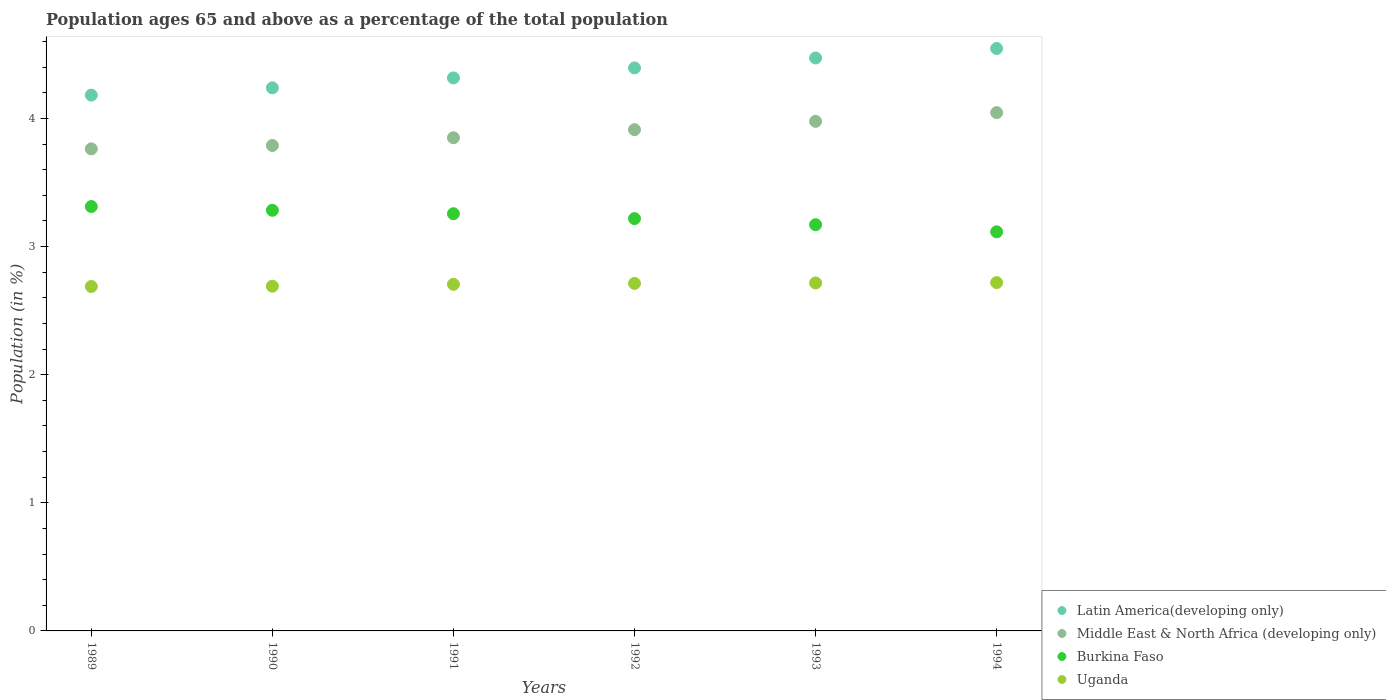What is the percentage of the population ages 65 and above in Burkina Faso in 1994?
Provide a succinct answer. 3.11. Across all years, what is the maximum percentage of the population ages 65 and above in Uganda?
Ensure brevity in your answer.  2.72. Across all years, what is the minimum percentage of the population ages 65 and above in Uganda?
Offer a very short reply. 2.69. In which year was the percentage of the population ages 65 and above in Middle East & North Africa (developing only) maximum?
Your answer should be compact. 1994. What is the total percentage of the population ages 65 and above in Latin America(developing only) in the graph?
Give a very brief answer. 26.15. What is the difference between the percentage of the population ages 65 and above in Middle East & North Africa (developing only) in 1991 and that in 1994?
Make the answer very short. -0.2. What is the difference between the percentage of the population ages 65 and above in Middle East & North Africa (developing only) in 1993 and the percentage of the population ages 65 and above in Burkina Faso in 1991?
Your response must be concise. 0.72. What is the average percentage of the population ages 65 and above in Middle East & North Africa (developing only) per year?
Give a very brief answer. 3.89. In the year 1993, what is the difference between the percentage of the population ages 65 and above in Middle East & North Africa (developing only) and percentage of the population ages 65 and above in Latin America(developing only)?
Keep it short and to the point. -0.49. In how many years, is the percentage of the population ages 65 and above in Latin America(developing only) greater than 4?
Your response must be concise. 6. What is the ratio of the percentage of the population ages 65 and above in Middle East & North Africa (developing only) in 1991 to that in 1993?
Offer a very short reply. 0.97. What is the difference between the highest and the second highest percentage of the population ages 65 and above in Latin America(developing only)?
Provide a succinct answer. 0.07. What is the difference between the highest and the lowest percentage of the population ages 65 and above in Middle East & North Africa (developing only)?
Make the answer very short. 0.28. In how many years, is the percentage of the population ages 65 and above in Burkina Faso greater than the average percentage of the population ages 65 and above in Burkina Faso taken over all years?
Your response must be concise. 3. Is the sum of the percentage of the population ages 65 and above in Burkina Faso in 1992 and 1994 greater than the maximum percentage of the population ages 65 and above in Uganda across all years?
Your response must be concise. Yes. Is it the case that in every year, the sum of the percentage of the population ages 65 and above in Latin America(developing only) and percentage of the population ages 65 and above in Burkina Faso  is greater than the sum of percentage of the population ages 65 and above in Middle East & North Africa (developing only) and percentage of the population ages 65 and above in Uganda?
Provide a succinct answer. No. Is it the case that in every year, the sum of the percentage of the population ages 65 and above in Uganda and percentage of the population ages 65 and above in Middle East & North Africa (developing only)  is greater than the percentage of the population ages 65 and above in Latin America(developing only)?
Provide a short and direct response. Yes. Does the percentage of the population ages 65 and above in Uganda monotonically increase over the years?
Ensure brevity in your answer.  Yes. Is the percentage of the population ages 65 and above in Middle East & North Africa (developing only) strictly greater than the percentage of the population ages 65 and above in Burkina Faso over the years?
Keep it short and to the point. Yes. Are the values on the major ticks of Y-axis written in scientific E-notation?
Your response must be concise. No. Does the graph contain any zero values?
Offer a terse response. No. Does the graph contain grids?
Provide a short and direct response. No. Where does the legend appear in the graph?
Your response must be concise. Bottom right. How many legend labels are there?
Keep it short and to the point. 4. How are the legend labels stacked?
Provide a short and direct response. Vertical. What is the title of the graph?
Your response must be concise. Population ages 65 and above as a percentage of the total population. Does "Central Europe" appear as one of the legend labels in the graph?
Provide a short and direct response. No. What is the label or title of the Y-axis?
Give a very brief answer. Population (in %). What is the Population (in %) in Latin America(developing only) in 1989?
Give a very brief answer. 4.18. What is the Population (in %) of Middle East & North Africa (developing only) in 1989?
Ensure brevity in your answer.  3.76. What is the Population (in %) of Burkina Faso in 1989?
Make the answer very short. 3.31. What is the Population (in %) in Uganda in 1989?
Make the answer very short. 2.69. What is the Population (in %) of Latin America(developing only) in 1990?
Your answer should be compact. 4.24. What is the Population (in %) of Middle East & North Africa (developing only) in 1990?
Your answer should be very brief. 3.79. What is the Population (in %) of Burkina Faso in 1990?
Give a very brief answer. 3.28. What is the Population (in %) of Uganda in 1990?
Ensure brevity in your answer.  2.69. What is the Population (in %) in Latin America(developing only) in 1991?
Provide a succinct answer. 4.32. What is the Population (in %) in Middle East & North Africa (developing only) in 1991?
Your response must be concise. 3.85. What is the Population (in %) of Burkina Faso in 1991?
Offer a very short reply. 3.26. What is the Population (in %) in Uganda in 1991?
Provide a short and direct response. 2.71. What is the Population (in %) in Latin America(developing only) in 1992?
Your response must be concise. 4.39. What is the Population (in %) in Middle East & North Africa (developing only) in 1992?
Your response must be concise. 3.91. What is the Population (in %) of Burkina Faso in 1992?
Your answer should be compact. 3.22. What is the Population (in %) in Uganda in 1992?
Your answer should be compact. 2.71. What is the Population (in %) in Latin America(developing only) in 1993?
Your answer should be compact. 4.47. What is the Population (in %) in Middle East & North Africa (developing only) in 1993?
Make the answer very short. 3.98. What is the Population (in %) of Burkina Faso in 1993?
Provide a succinct answer. 3.17. What is the Population (in %) in Uganda in 1993?
Offer a terse response. 2.72. What is the Population (in %) of Latin America(developing only) in 1994?
Give a very brief answer. 4.55. What is the Population (in %) of Middle East & North Africa (developing only) in 1994?
Offer a terse response. 4.04. What is the Population (in %) in Burkina Faso in 1994?
Offer a terse response. 3.11. What is the Population (in %) of Uganda in 1994?
Your answer should be compact. 2.72. Across all years, what is the maximum Population (in %) in Latin America(developing only)?
Your answer should be very brief. 4.55. Across all years, what is the maximum Population (in %) in Middle East & North Africa (developing only)?
Provide a short and direct response. 4.04. Across all years, what is the maximum Population (in %) of Burkina Faso?
Make the answer very short. 3.31. Across all years, what is the maximum Population (in %) in Uganda?
Your answer should be compact. 2.72. Across all years, what is the minimum Population (in %) in Latin America(developing only)?
Your answer should be very brief. 4.18. Across all years, what is the minimum Population (in %) of Middle East & North Africa (developing only)?
Make the answer very short. 3.76. Across all years, what is the minimum Population (in %) of Burkina Faso?
Your response must be concise. 3.11. Across all years, what is the minimum Population (in %) in Uganda?
Provide a short and direct response. 2.69. What is the total Population (in %) of Latin America(developing only) in the graph?
Your response must be concise. 26.15. What is the total Population (in %) in Middle East & North Africa (developing only) in the graph?
Your answer should be very brief. 23.33. What is the total Population (in %) in Burkina Faso in the graph?
Make the answer very short. 19.35. What is the total Population (in %) in Uganda in the graph?
Your answer should be compact. 16.23. What is the difference between the Population (in %) in Latin America(developing only) in 1989 and that in 1990?
Provide a short and direct response. -0.06. What is the difference between the Population (in %) in Middle East & North Africa (developing only) in 1989 and that in 1990?
Your response must be concise. -0.03. What is the difference between the Population (in %) in Burkina Faso in 1989 and that in 1990?
Your answer should be very brief. 0.03. What is the difference between the Population (in %) of Uganda in 1989 and that in 1990?
Your answer should be very brief. -0. What is the difference between the Population (in %) in Latin America(developing only) in 1989 and that in 1991?
Provide a short and direct response. -0.13. What is the difference between the Population (in %) in Middle East & North Africa (developing only) in 1989 and that in 1991?
Ensure brevity in your answer.  -0.09. What is the difference between the Population (in %) of Burkina Faso in 1989 and that in 1991?
Keep it short and to the point. 0.06. What is the difference between the Population (in %) in Uganda in 1989 and that in 1991?
Ensure brevity in your answer.  -0.02. What is the difference between the Population (in %) in Latin America(developing only) in 1989 and that in 1992?
Make the answer very short. -0.21. What is the difference between the Population (in %) in Middle East & North Africa (developing only) in 1989 and that in 1992?
Offer a very short reply. -0.15. What is the difference between the Population (in %) in Burkina Faso in 1989 and that in 1992?
Make the answer very short. 0.09. What is the difference between the Population (in %) in Uganda in 1989 and that in 1992?
Your answer should be very brief. -0.02. What is the difference between the Population (in %) in Latin America(developing only) in 1989 and that in 1993?
Make the answer very short. -0.29. What is the difference between the Population (in %) of Middle East & North Africa (developing only) in 1989 and that in 1993?
Your response must be concise. -0.21. What is the difference between the Population (in %) of Burkina Faso in 1989 and that in 1993?
Provide a short and direct response. 0.14. What is the difference between the Population (in %) in Uganda in 1989 and that in 1993?
Give a very brief answer. -0.03. What is the difference between the Population (in %) in Latin America(developing only) in 1989 and that in 1994?
Your response must be concise. -0.36. What is the difference between the Population (in %) in Middle East & North Africa (developing only) in 1989 and that in 1994?
Make the answer very short. -0.28. What is the difference between the Population (in %) in Burkina Faso in 1989 and that in 1994?
Provide a short and direct response. 0.2. What is the difference between the Population (in %) of Uganda in 1989 and that in 1994?
Keep it short and to the point. -0.03. What is the difference between the Population (in %) in Latin America(developing only) in 1990 and that in 1991?
Your response must be concise. -0.08. What is the difference between the Population (in %) in Middle East & North Africa (developing only) in 1990 and that in 1991?
Provide a succinct answer. -0.06. What is the difference between the Population (in %) of Burkina Faso in 1990 and that in 1991?
Your response must be concise. 0.03. What is the difference between the Population (in %) in Uganda in 1990 and that in 1991?
Give a very brief answer. -0.01. What is the difference between the Population (in %) in Latin America(developing only) in 1990 and that in 1992?
Give a very brief answer. -0.16. What is the difference between the Population (in %) of Middle East & North Africa (developing only) in 1990 and that in 1992?
Offer a terse response. -0.12. What is the difference between the Population (in %) of Burkina Faso in 1990 and that in 1992?
Offer a terse response. 0.07. What is the difference between the Population (in %) in Uganda in 1990 and that in 1992?
Make the answer very short. -0.02. What is the difference between the Population (in %) in Latin America(developing only) in 1990 and that in 1993?
Offer a terse response. -0.23. What is the difference between the Population (in %) in Middle East & North Africa (developing only) in 1990 and that in 1993?
Provide a succinct answer. -0.19. What is the difference between the Population (in %) of Burkina Faso in 1990 and that in 1993?
Your answer should be compact. 0.11. What is the difference between the Population (in %) of Uganda in 1990 and that in 1993?
Keep it short and to the point. -0.03. What is the difference between the Population (in %) in Latin America(developing only) in 1990 and that in 1994?
Offer a terse response. -0.31. What is the difference between the Population (in %) of Middle East & North Africa (developing only) in 1990 and that in 1994?
Make the answer very short. -0.26. What is the difference between the Population (in %) in Burkina Faso in 1990 and that in 1994?
Give a very brief answer. 0.17. What is the difference between the Population (in %) of Uganda in 1990 and that in 1994?
Offer a very short reply. -0.03. What is the difference between the Population (in %) in Latin America(developing only) in 1991 and that in 1992?
Provide a succinct answer. -0.08. What is the difference between the Population (in %) in Middle East & North Africa (developing only) in 1991 and that in 1992?
Your answer should be very brief. -0.06. What is the difference between the Population (in %) in Burkina Faso in 1991 and that in 1992?
Offer a very short reply. 0.04. What is the difference between the Population (in %) of Uganda in 1991 and that in 1992?
Offer a terse response. -0.01. What is the difference between the Population (in %) of Latin America(developing only) in 1991 and that in 1993?
Your answer should be very brief. -0.16. What is the difference between the Population (in %) in Middle East & North Africa (developing only) in 1991 and that in 1993?
Offer a very short reply. -0.13. What is the difference between the Population (in %) of Burkina Faso in 1991 and that in 1993?
Give a very brief answer. 0.09. What is the difference between the Population (in %) of Uganda in 1991 and that in 1993?
Offer a terse response. -0.01. What is the difference between the Population (in %) of Latin America(developing only) in 1991 and that in 1994?
Provide a short and direct response. -0.23. What is the difference between the Population (in %) of Middle East & North Africa (developing only) in 1991 and that in 1994?
Offer a very short reply. -0.2. What is the difference between the Population (in %) in Burkina Faso in 1991 and that in 1994?
Your answer should be very brief. 0.14. What is the difference between the Population (in %) of Uganda in 1991 and that in 1994?
Ensure brevity in your answer.  -0.01. What is the difference between the Population (in %) of Latin America(developing only) in 1992 and that in 1993?
Offer a very short reply. -0.08. What is the difference between the Population (in %) of Middle East & North Africa (developing only) in 1992 and that in 1993?
Your answer should be very brief. -0.07. What is the difference between the Population (in %) in Burkina Faso in 1992 and that in 1993?
Provide a succinct answer. 0.05. What is the difference between the Population (in %) in Uganda in 1992 and that in 1993?
Your answer should be compact. -0. What is the difference between the Population (in %) of Latin America(developing only) in 1992 and that in 1994?
Make the answer very short. -0.15. What is the difference between the Population (in %) in Middle East & North Africa (developing only) in 1992 and that in 1994?
Provide a short and direct response. -0.13. What is the difference between the Population (in %) in Burkina Faso in 1992 and that in 1994?
Offer a very short reply. 0.1. What is the difference between the Population (in %) in Uganda in 1992 and that in 1994?
Your answer should be compact. -0.01. What is the difference between the Population (in %) of Latin America(developing only) in 1993 and that in 1994?
Your answer should be very brief. -0.07. What is the difference between the Population (in %) of Middle East & North Africa (developing only) in 1993 and that in 1994?
Make the answer very short. -0.07. What is the difference between the Population (in %) of Burkina Faso in 1993 and that in 1994?
Provide a succinct answer. 0.06. What is the difference between the Population (in %) of Uganda in 1993 and that in 1994?
Keep it short and to the point. -0. What is the difference between the Population (in %) in Latin America(developing only) in 1989 and the Population (in %) in Middle East & North Africa (developing only) in 1990?
Your answer should be compact. 0.39. What is the difference between the Population (in %) of Latin America(developing only) in 1989 and the Population (in %) of Burkina Faso in 1990?
Keep it short and to the point. 0.9. What is the difference between the Population (in %) in Latin America(developing only) in 1989 and the Population (in %) in Uganda in 1990?
Give a very brief answer. 1.49. What is the difference between the Population (in %) in Middle East & North Africa (developing only) in 1989 and the Population (in %) in Burkina Faso in 1990?
Keep it short and to the point. 0.48. What is the difference between the Population (in %) of Middle East & North Africa (developing only) in 1989 and the Population (in %) of Uganda in 1990?
Your response must be concise. 1.07. What is the difference between the Population (in %) in Burkina Faso in 1989 and the Population (in %) in Uganda in 1990?
Your answer should be very brief. 0.62. What is the difference between the Population (in %) in Latin America(developing only) in 1989 and the Population (in %) in Middle East & North Africa (developing only) in 1991?
Ensure brevity in your answer.  0.33. What is the difference between the Population (in %) of Latin America(developing only) in 1989 and the Population (in %) of Burkina Faso in 1991?
Provide a short and direct response. 0.93. What is the difference between the Population (in %) in Latin America(developing only) in 1989 and the Population (in %) in Uganda in 1991?
Your answer should be very brief. 1.48. What is the difference between the Population (in %) of Middle East & North Africa (developing only) in 1989 and the Population (in %) of Burkina Faso in 1991?
Ensure brevity in your answer.  0.51. What is the difference between the Population (in %) of Middle East & North Africa (developing only) in 1989 and the Population (in %) of Uganda in 1991?
Give a very brief answer. 1.06. What is the difference between the Population (in %) in Burkina Faso in 1989 and the Population (in %) in Uganda in 1991?
Your answer should be very brief. 0.61. What is the difference between the Population (in %) in Latin America(developing only) in 1989 and the Population (in %) in Middle East & North Africa (developing only) in 1992?
Offer a very short reply. 0.27. What is the difference between the Population (in %) in Latin America(developing only) in 1989 and the Population (in %) in Burkina Faso in 1992?
Your answer should be compact. 0.96. What is the difference between the Population (in %) in Latin America(developing only) in 1989 and the Population (in %) in Uganda in 1992?
Your answer should be very brief. 1.47. What is the difference between the Population (in %) in Middle East & North Africa (developing only) in 1989 and the Population (in %) in Burkina Faso in 1992?
Offer a terse response. 0.54. What is the difference between the Population (in %) in Middle East & North Africa (developing only) in 1989 and the Population (in %) in Uganda in 1992?
Give a very brief answer. 1.05. What is the difference between the Population (in %) of Burkina Faso in 1989 and the Population (in %) of Uganda in 1992?
Ensure brevity in your answer.  0.6. What is the difference between the Population (in %) of Latin America(developing only) in 1989 and the Population (in %) of Middle East & North Africa (developing only) in 1993?
Keep it short and to the point. 0.2. What is the difference between the Population (in %) in Latin America(developing only) in 1989 and the Population (in %) in Burkina Faso in 1993?
Keep it short and to the point. 1.01. What is the difference between the Population (in %) in Latin America(developing only) in 1989 and the Population (in %) in Uganda in 1993?
Keep it short and to the point. 1.47. What is the difference between the Population (in %) of Middle East & North Africa (developing only) in 1989 and the Population (in %) of Burkina Faso in 1993?
Your answer should be very brief. 0.59. What is the difference between the Population (in %) in Middle East & North Africa (developing only) in 1989 and the Population (in %) in Uganda in 1993?
Give a very brief answer. 1.05. What is the difference between the Population (in %) of Burkina Faso in 1989 and the Population (in %) of Uganda in 1993?
Ensure brevity in your answer.  0.6. What is the difference between the Population (in %) in Latin America(developing only) in 1989 and the Population (in %) in Middle East & North Africa (developing only) in 1994?
Your response must be concise. 0.14. What is the difference between the Population (in %) in Latin America(developing only) in 1989 and the Population (in %) in Burkina Faso in 1994?
Keep it short and to the point. 1.07. What is the difference between the Population (in %) of Latin America(developing only) in 1989 and the Population (in %) of Uganda in 1994?
Ensure brevity in your answer.  1.46. What is the difference between the Population (in %) of Middle East & North Africa (developing only) in 1989 and the Population (in %) of Burkina Faso in 1994?
Keep it short and to the point. 0.65. What is the difference between the Population (in %) in Middle East & North Africa (developing only) in 1989 and the Population (in %) in Uganda in 1994?
Provide a short and direct response. 1.04. What is the difference between the Population (in %) in Burkina Faso in 1989 and the Population (in %) in Uganda in 1994?
Provide a short and direct response. 0.59. What is the difference between the Population (in %) of Latin America(developing only) in 1990 and the Population (in %) of Middle East & North Africa (developing only) in 1991?
Provide a succinct answer. 0.39. What is the difference between the Population (in %) in Latin America(developing only) in 1990 and the Population (in %) in Burkina Faso in 1991?
Keep it short and to the point. 0.98. What is the difference between the Population (in %) of Latin America(developing only) in 1990 and the Population (in %) of Uganda in 1991?
Provide a succinct answer. 1.53. What is the difference between the Population (in %) of Middle East & North Africa (developing only) in 1990 and the Population (in %) of Burkina Faso in 1991?
Ensure brevity in your answer.  0.53. What is the difference between the Population (in %) of Middle East & North Africa (developing only) in 1990 and the Population (in %) of Uganda in 1991?
Your response must be concise. 1.08. What is the difference between the Population (in %) of Burkina Faso in 1990 and the Population (in %) of Uganda in 1991?
Your response must be concise. 0.58. What is the difference between the Population (in %) in Latin America(developing only) in 1990 and the Population (in %) in Middle East & North Africa (developing only) in 1992?
Your response must be concise. 0.33. What is the difference between the Population (in %) in Latin America(developing only) in 1990 and the Population (in %) in Burkina Faso in 1992?
Offer a terse response. 1.02. What is the difference between the Population (in %) in Latin America(developing only) in 1990 and the Population (in %) in Uganda in 1992?
Give a very brief answer. 1.53. What is the difference between the Population (in %) in Middle East & North Africa (developing only) in 1990 and the Population (in %) in Burkina Faso in 1992?
Your answer should be very brief. 0.57. What is the difference between the Population (in %) of Middle East & North Africa (developing only) in 1990 and the Population (in %) of Uganda in 1992?
Provide a succinct answer. 1.08. What is the difference between the Population (in %) of Burkina Faso in 1990 and the Population (in %) of Uganda in 1992?
Ensure brevity in your answer.  0.57. What is the difference between the Population (in %) of Latin America(developing only) in 1990 and the Population (in %) of Middle East & North Africa (developing only) in 1993?
Your response must be concise. 0.26. What is the difference between the Population (in %) in Latin America(developing only) in 1990 and the Population (in %) in Burkina Faso in 1993?
Ensure brevity in your answer.  1.07. What is the difference between the Population (in %) in Latin America(developing only) in 1990 and the Population (in %) in Uganda in 1993?
Ensure brevity in your answer.  1.52. What is the difference between the Population (in %) of Middle East & North Africa (developing only) in 1990 and the Population (in %) of Burkina Faso in 1993?
Give a very brief answer. 0.62. What is the difference between the Population (in %) of Middle East & North Africa (developing only) in 1990 and the Population (in %) of Uganda in 1993?
Give a very brief answer. 1.07. What is the difference between the Population (in %) of Burkina Faso in 1990 and the Population (in %) of Uganda in 1993?
Your response must be concise. 0.57. What is the difference between the Population (in %) in Latin America(developing only) in 1990 and the Population (in %) in Middle East & North Africa (developing only) in 1994?
Provide a short and direct response. 0.19. What is the difference between the Population (in %) of Latin America(developing only) in 1990 and the Population (in %) of Burkina Faso in 1994?
Give a very brief answer. 1.12. What is the difference between the Population (in %) in Latin America(developing only) in 1990 and the Population (in %) in Uganda in 1994?
Your response must be concise. 1.52. What is the difference between the Population (in %) of Middle East & North Africa (developing only) in 1990 and the Population (in %) of Burkina Faso in 1994?
Your answer should be very brief. 0.67. What is the difference between the Population (in %) in Middle East & North Africa (developing only) in 1990 and the Population (in %) in Uganda in 1994?
Your answer should be compact. 1.07. What is the difference between the Population (in %) in Burkina Faso in 1990 and the Population (in %) in Uganda in 1994?
Provide a short and direct response. 0.56. What is the difference between the Population (in %) in Latin America(developing only) in 1991 and the Population (in %) in Middle East & North Africa (developing only) in 1992?
Your answer should be very brief. 0.4. What is the difference between the Population (in %) of Latin America(developing only) in 1991 and the Population (in %) of Burkina Faso in 1992?
Keep it short and to the point. 1.1. What is the difference between the Population (in %) of Latin America(developing only) in 1991 and the Population (in %) of Uganda in 1992?
Offer a very short reply. 1.6. What is the difference between the Population (in %) in Middle East & North Africa (developing only) in 1991 and the Population (in %) in Burkina Faso in 1992?
Offer a terse response. 0.63. What is the difference between the Population (in %) in Middle East & North Africa (developing only) in 1991 and the Population (in %) in Uganda in 1992?
Your answer should be compact. 1.14. What is the difference between the Population (in %) in Burkina Faso in 1991 and the Population (in %) in Uganda in 1992?
Give a very brief answer. 0.54. What is the difference between the Population (in %) of Latin America(developing only) in 1991 and the Population (in %) of Middle East & North Africa (developing only) in 1993?
Give a very brief answer. 0.34. What is the difference between the Population (in %) of Latin America(developing only) in 1991 and the Population (in %) of Burkina Faso in 1993?
Offer a terse response. 1.15. What is the difference between the Population (in %) in Latin America(developing only) in 1991 and the Population (in %) in Uganda in 1993?
Ensure brevity in your answer.  1.6. What is the difference between the Population (in %) in Middle East & North Africa (developing only) in 1991 and the Population (in %) in Burkina Faso in 1993?
Provide a short and direct response. 0.68. What is the difference between the Population (in %) in Middle East & North Africa (developing only) in 1991 and the Population (in %) in Uganda in 1993?
Give a very brief answer. 1.13. What is the difference between the Population (in %) of Burkina Faso in 1991 and the Population (in %) of Uganda in 1993?
Your response must be concise. 0.54. What is the difference between the Population (in %) in Latin America(developing only) in 1991 and the Population (in %) in Middle East & North Africa (developing only) in 1994?
Make the answer very short. 0.27. What is the difference between the Population (in %) in Latin America(developing only) in 1991 and the Population (in %) in Burkina Faso in 1994?
Your response must be concise. 1.2. What is the difference between the Population (in %) of Latin America(developing only) in 1991 and the Population (in %) of Uganda in 1994?
Provide a short and direct response. 1.6. What is the difference between the Population (in %) in Middle East & North Africa (developing only) in 1991 and the Population (in %) in Burkina Faso in 1994?
Ensure brevity in your answer.  0.73. What is the difference between the Population (in %) of Middle East & North Africa (developing only) in 1991 and the Population (in %) of Uganda in 1994?
Ensure brevity in your answer.  1.13. What is the difference between the Population (in %) in Burkina Faso in 1991 and the Population (in %) in Uganda in 1994?
Make the answer very short. 0.54. What is the difference between the Population (in %) in Latin America(developing only) in 1992 and the Population (in %) in Middle East & North Africa (developing only) in 1993?
Offer a terse response. 0.42. What is the difference between the Population (in %) of Latin America(developing only) in 1992 and the Population (in %) of Burkina Faso in 1993?
Ensure brevity in your answer.  1.22. What is the difference between the Population (in %) of Latin America(developing only) in 1992 and the Population (in %) of Uganda in 1993?
Your response must be concise. 1.68. What is the difference between the Population (in %) of Middle East & North Africa (developing only) in 1992 and the Population (in %) of Burkina Faso in 1993?
Offer a terse response. 0.74. What is the difference between the Population (in %) in Middle East & North Africa (developing only) in 1992 and the Population (in %) in Uganda in 1993?
Give a very brief answer. 1.2. What is the difference between the Population (in %) of Burkina Faso in 1992 and the Population (in %) of Uganda in 1993?
Your answer should be compact. 0.5. What is the difference between the Population (in %) in Latin America(developing only) in 1992 and the Population (in %) in Middle East & North Africa (developing only) in 1994?
Ensure brevity in your answer.  0.35. What is the difference between the Population (in %) of Latin America(developing only) in 1992 and the Population (in %) of Burkina Faso in 1994?
Give a very brief answer. 1.28. What is the difference between the Population (in %) of Latin America(developing only) in 1992 and the Population (in %) of Uganda in 1994?
Your response must be concise. 1.68. What is the difference between the Population (in %) of Middle East & North Africa (developing only) in 1992 and the Population (in %) of Burkina Faso in 1994?
Make the answer very short. 0.8. What is the difference between the Population (in %) in Middle East & North Africa (developing only) in 1992 and the Population (in %) in Uganda in 1994?
Provide a short and direct response. 1.19. What is the difference between the Population (in %) of Burkina Faso in 1992 and the Population (in %) of Uganda in 1994?
Ensure brevity in your answer.  0.5. What is the difference between the Population (in %) of Latin America(developing only) in 1993 and the Population (in %) of Middle East & North Africa (developing only) in 1994?
Your answer should be compact. 0.43. What is the difference between the Population (in %) of Latin America(developing only) in 1993 and the Population (in %) of Burkina Faso in 1994?
Provide a short and direct response. 1.36. What is the difference between the Population (in %) in Latin America(developing only) in 1993 and the Population (in %) in Uganda in 1994?
Ensure brevity in your answer.  1.75. What is the difference between the Population (in %) of Middle East & North Africa (developing only) in 1993 and the Population (in %) of Burkina Faso in 1994?
Offer a terse response. 0.86. What is the difference between the Population (in %) in Middle East & North Africa (developing only) in 1993 and the Population (in %) in Uganda in 1994?
Provide a short and direct response. 1.26. What is the difference between the Population (in %) of Burkina Faso in 1993 and the Population (in %) of Uganda in 1994?
Keep it short and to the point. 0.45. What is the average Population (in %) in Latin America(developing only) per year?
Your response must be concise. 4.36. What is the average Population (in %) in Middle East & North Africa (developing only) per year?
Ensure brevity in your answer.  3.89. What is the average Population (in %) of Burkina Faso per year?
Give a very brief answer. 3.23. What is the average Population (in %) of Uganda per year?
Provide a succinct answer. 2.71. In the year 1989, what is the difference between the Population (in %) in Latin America(developing only) and Population (in %) in Middle East & North Africa (developing only)?
Offer a very short reply. 0.42. In the year 1989, what is the difference between the Population (in %) in Latin America(developing only) and Population (in %) in Burkina Faso?
Provide a short and direct response. 0.87. In the year 1989, what is the difference between the Population (in %) in Latin America(developing only) and Population (in %) in Uganda?
Provide a succinct answer. 1.49. In the year 1989, what is the difference between the Population (in %) of Middle East & North Africa (developing only) and Population (in %) of Burkina Faso?
Give a very brief answer. 0.45. In the year 1989, what is the difference between the Population (in %) of Middle East & North Africa (developing only) and Population (in %) of Uganda?
Provide a succinct answer. 1.07. In the year 1989, what is the difference between the Population (in %) of Burkina Faso and Population (in %) of Uganda?
Ensure brevity in your answer.  0.62. In the year 1990, what is the difference between the Population (in %) of Latin America(developing only) and Population (in %) of Middle East & North Africa (developing only)?
Provide a short and direct response. 0.45. In the year 1990, what is the difference between the Population (in %) of Latin America(developing only) and Population (in %) of Burkina Faso?
Your response must be concise. 0.96. In the year 1990, what is the difference between the Population (in %) in Latin America(developing only) and Population (in %) in Uganda?
Ensure brevity in your answer.  1.55. In the year 1990, what is the difference between the Population (in %) in Middle East & North Africa (developing only) and Population (in %) in Burkina Faso?
Offer a very short reply. 0.51. In the year 1990, what is the difference between the Population (in %) in Middle East & North Africa (developing only) and Population (in %) in Uganda?
Your response must be concise. 1.1. In the year 1990, what is the difference between the Population (in %) of Burkina Faso and Population (in %) of Uganda?
Provide a succinct answer. 0.59. In the year 1991, what is the difference between the Population (in %) of Latin America(developing only) and Population (in %) of Middle East & North Africa (developing only)?
Your answer should be compact. 0.47. In the year 1991, what is the difference between the Population (in %) in Latin America(developing only) and Population (in %) in Burkina Faso?
Provide a succinct answer. 1.06. In the year 1991, what is the difference between the Population (in %) in Latin America(developing only) and Population (in %) in Uganda?
Provide a succinct answer. 1.61. In the year 1991, what is the difference between the Population (in %) in Middle East & North Africa (developing only) and Population (in %) in Burkina Faso?
Keep it short and to the point. 0.59. In the year 1991, what is the difference between the Population (in %) of Middle East & North Africa (developing only) and Population (in %) of Uganda?
Make the answer very short. 1.14. In the year 1991, what is the difference between the Population (in %) in Burkina Faso and Population (in %) in Uganda?
Your response must be concise. 0.55. In the year 1992, what is the difference between the Population (in %) in Latin America(developing only) and Population (in %) in Middle East & North Africa (developing only)?
Provide a succinct answer. 0.48. In the year 1992, what is the difference between the Population (in %) of Latin America(developing only) and Population (in %) of Burkina Faso?
Ensure brevity in your answer.  1.18. In the year 1992, what is the difference between the Population (in %) of Latin America(developing only) and Population (in %) of Uganda?
Your answer should be compact. 1.68. In the year 1992, what is the difference between the Population (in %) of Middle East & North Africa (developing only) and Population (in %) of Burkina Faso?
Make the answer very short. 0.69. In the year 1992, what is the difference between the Population (in %) of Middle East & North Africa (developing only) and Population (in %) of Uganda?
Keep it short and to the point. 1.2. In the year 1992, what is the difference between the Population (in %) in Burkina Faso and Population (in %) in Uganda?
Give a very brief answer. 0.51. In the year 1993, what is the difference between the Population (in %) in Latin America(developing only) and Population (in %) in Middle East & North Africa (developing only)?
Keep it short and to the point. 0.49. In the year 1993, what is the difference between the Population (in %) of Latin America(developing only) and Population (in %) of Burkina Faso?
Offer a terse response. 1.3. In the year 1993, what is the difference between the Population (in %) in Latin America(developing only) and Population (in %) in Uganda?
Make the answer very short. 1.76. In the year 1993, what is the difference between the Population (in %) in Middle East & North Africa (developing only) and Population (in %) in Burkina Faso?
Make the answer very short. 0.81. In the year 1993, what is the difference between the Population (in %) of Middle East & North Africa (developing only) and Population (in %) of Uganda?
Your answer should be compact. 1.26. In the year 1993, what is the difference between the Population (in %) of Burkina Faso and Population (in %) of Uganda?
Give a very brief answer. 0.45. In the year 1994, what is the difference between the Population (in %) of Latin America(developing only) and Population (in %) of Middle East & North Africa (developing only)?
Your answer should be compact. 0.5. In the year 1994, what is the difference between the Population (in %) of Latin America(developing only) and Population (in %) of Burkina Faso?
Provide a succinct answer. 1.43. In the year 1994, what is the difference between the Population (in %) of Latin America(developing only) and Population (in %) of Uganda?
Keep it short and to the point. 1.83. In the year 1994, what is the difference between the Population (in %) of Middle East & North Africa (developing only) and Population (in %) of Burkina Faso?
Your answer should be compact. 0.93. In the year 1994, what is the difference between the Population (in %) of Middle East & North Africa (developing only) and Population (in %) of Uganda?
Ensure brevity in your answer.  1.33. In the year 1994, what is the difference between the Population (in %) of Burkina Faso and Population (in %) of Uganda?
Your answer should be very brief. 0.4. What is the ratio of the Population (in %) in Latin America(developing only) in 1989 to that in 1990?
Make the answer very short. 0.99. What is the ratio of the Population (in %) of Middle East & North Africa (developing only) in 1989 to that in 1990?
Ensure brevity in your answer.  0.99. What is the ratio of the Population (in %) of Burkina Faso in 1989 to that in 1990?
Offer a terse response. 1.01. What is the ratio of the Population (in %) in Latin America(developing only) in 1989 to that in 1991?
Offer a terse response. 0.97. What is the ratio of the Population (in %) of Middle East & North Africa (developing only) in 1989 to that in 1991?
Offer a very short reply. 0.98. What is the ratio of the Population (in %) of Burkina Faso in 1989 to that in 1991?
Your answer should be compact. 1.02. What is the ratio of the Population (in %) in Latin America(developing only) in 1989 to that in 1992?
Make the answer very short. 0.95. What is the ratio of the Population (in %) of Middle East & North Africa (developing only) in 1989 to that in 1992?
Offer a terse response. 0.96. What is the ratio of the Population (in %) of Burkina Faso in 1989 to that in 1992?
Make the answer very short. 1.03. What is the ratio of the Population (in %) of Uganda in 1989 to that in 1992?
Ensure brevity in your answer.  0.99. What is the ratio of the Population (in %) of Latin America(developing only) in 1989 to that in 1993?
Your answer should be very brief. 0.94. What is the ratio of the Population (in %) in Middle East & North Africa (developing only) in 1989 to that in 1993?
Give a very brief answer. 0.95. What is the ratio of the Population (in %) of Burkina Faso in 1989 to that in 1993?
Your answer should be compact. 1.04. What is the ratio of the Population (in %) in Uganda in 1989 to that in 1993?
Offer a terse response. 0.99. What is the ratio of the Population (in %) in Latin America(developing only) in 1989 to that in 1994?
Make the answer very short. 0.92. What is the ratio of the Population (in %) of Middle East & North Africa (developing only) in 1989 to that in 1994?
Give a very brief answer. 0.93. What is the ratio of the Population (in %) in Burkina Faso in 1989 to that in 1994?
Offer a terse response. 1.06. What is the ratio of the Population (in %) in Latin America(developing only) in 1990 to that in 1991?
Offer a very short reply. 0.98. What is the ratio of the Population (in %) in Middle East & North Africa (developing only) in 1990 to that in 1991?
Your response must be concise. 0.98. What is the ratio of the Population (in %) in Burkina Faso in 1990 to that in 1991?
Your answer should be very brief. 1.01. What is the ratio of the Population (in %) in Latin America(developing only) in 1990 to that in 1992?
Your answer should be compact. 0.96. What is the ratio of the Population (in %) in Middle East & North Africa (developing only) in 1990 to that in 1992?
Keep it short and to the point. 0.97. What is the ratio of the Population (in %) in Burkina Faso in 1990 to that in 1992?
Provide a short and direct response. 1.02. What is the ratio of the Population (in %) of Uganda in 1990 to that in 1992?
Your answer should be compact. 0.99. What is the ratio of the Population (in %) of Latin America(developing only) in 1990 to that in 1993?
Keep it short and to the point. 0.95. What is the ratio of the Population (in %) in Middle East & North Africa (developing only) in 1990 to that in 1993?
Your answer should be very brief. 0.95. What is the ratio of the Population (in %) in Burkina Faso in 1990 to that in 1993?
Your answer should be compact. 1.04. What is the ratio of the Population (in %) in Latin America(developing only) in 1990 to that in 1994?
Provide a short and direct response. 0.93. What is the ratio of the Population (in %) in Middle East & North Africa (developing only) in 1990 to that in 1994?
Ensure brevity in your answer.  0.94. What is the ratio of the Population (in %) in Burkina Faso in 1990 to that in 1994?
Offer a very short reply. 1.05. What is the ratio of the Population (in %) of Uganda in 1990 to that in 1994?
Ensure brevity in your answer.  0.99. What is the ratio of the Population (in %) of Latin America(developing only) in 1991 to that in 1992?
Provide a succinct answer. 0.98. What is the ratio of the Population (in %) of Middle East & North Africa (developing only) in 1991 to that in 1992?
Ensure brevity in your answer.  0.98. What is the ratio of the Population (in %) of Burkina Faso in 1991 to that in 1992?
Your answer should be compact. 1.01. What is the ratio of the Population (in %) of Uganda in 1991 to that in 1992?
Your response must be concise. 1. What is the ratio of the Population (in %) of Latin America(developing only) in 1991 to that in 1993?
Keep it short and to the point. 0.97. What is the ratio of the Population (in %) in Middle East & North Africa (developing only) in 1991 to that in 1993?
Offer a very short reply. 0.97. What is the ratio of the Population (in %) in Uganda in 1991 to that in 1993?
Your answer should be compact. 1. What is the ratio of the Population (in %) in Latin America(developing only) in 1991 to that in 1994?
Your response must be concise. 0.95. What is the ratio of the Population (in %) of Middle East & North Africa (developing only) in 1991 to that in 1994?
Give a very brief answer. 0.95. What is the ratio of the Population (in %) of Burkina Faso in 1991 to that in 1994?
Make the answer very short. 1.05. What is the ratio of the Population (in %) of Latin America(developing only) in 1992 to that in 1993?
Your answer should be very brief. 0.98. What is the ratio of the Population (in %) of Middle East & North Africa (developing only) in 1992 to that in 1993?
Offer a terse response. 0.98. What is the ratio of the Population (in %) in Latin America(developing only) in 1992 to that in 1994?
Ensure brevity in your answer.  0.97. What is the ratio of the Population (in %) in Middle East & North Africa (developing only) in 1992 to that in 1994?
Provide a short and direct response. 0.97. What is the ratio of the Population (in %) in Burkina Faso in 1992 to that in 1994?
Your answer should be compact. 1.03. What is the ratio of the Population (in %) of Latin America(developing only) in 1993 to that in 1994?
Offer a very short reply. 0.98. What is the ratio of the Population (in %) in Middle East & North Africa (developing only) in 1993 to that in 1994?
Provide a succinct answer. 0.98. What is the ratio of the Population (in %) of Burkina Faso in 1993 to that in 1994?
Your answer should be very brief. 1.02. What is the difference between the highest and the second highest Population (in %) of Latin America(developing only)?
Give a very brief answer. 0.07. What is the difference between the highest and the second highest Population (in %) of Middle East & North Africa (developing only)?
Keep it short and to the point. 0.07. What is the difference between the highest and the second highest Population (in %) of Burkina Faso?
Provide a short and direct response. 0.03. What is the difference between the highest and the second highest Population (in %) of Uganda?
Keep it short and to the point. 0. What is the difference between the highest and the lowest Population (in %) in Latin America(developing only)?
Keep it short and to the point. 0.36. What is the difference between the highest and the lowest Population (in %) of Middle East & North Africa (developing only)?
Offer a very short reply. 0.28. What is the difference between the highest and the lowest Population (in %) in Burkina Faso?
Your response must be concise. 0.2. What is the difference between the highest and the lowest Population (in %) in Uganda?
Your answer should be very brief. 0.03. 